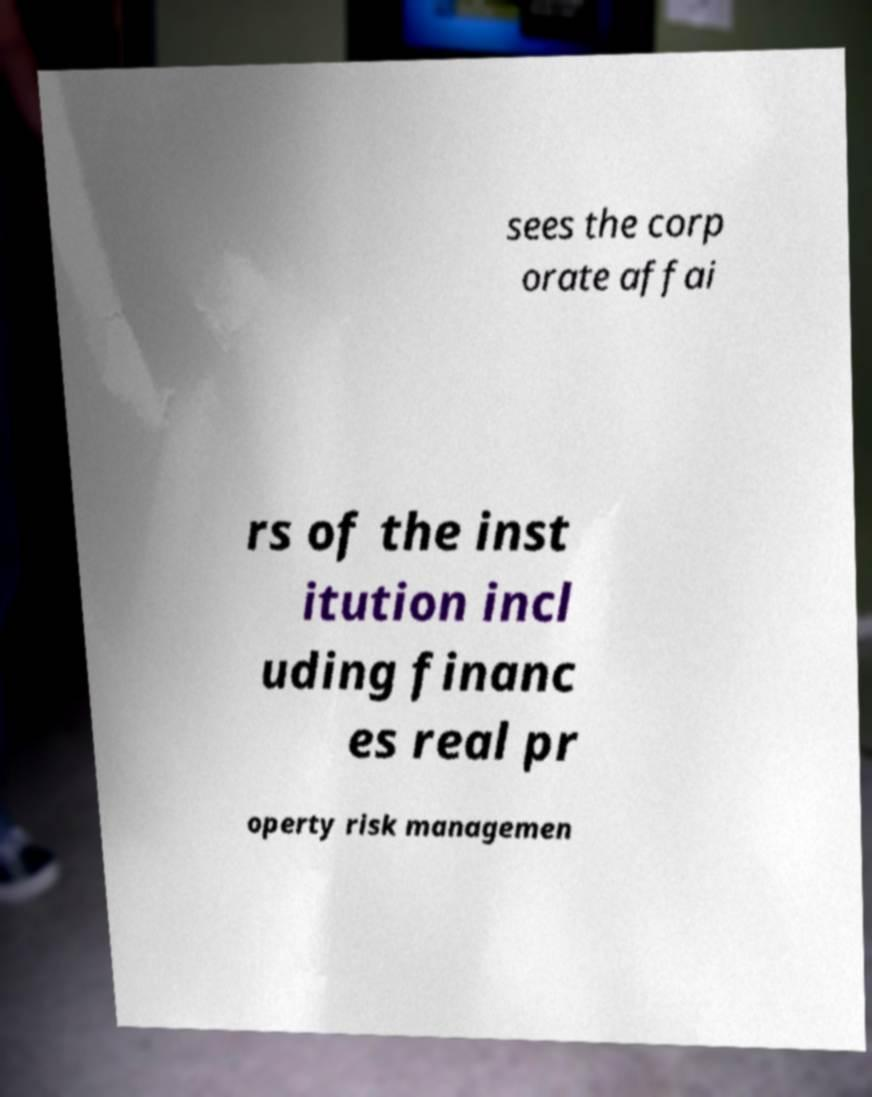There's text embedded in this image that I need extracted. Can you transcribe it verbatim? sees the corp orate affai rs of the inst itution incl uding financ es real pr operty risk managemen 